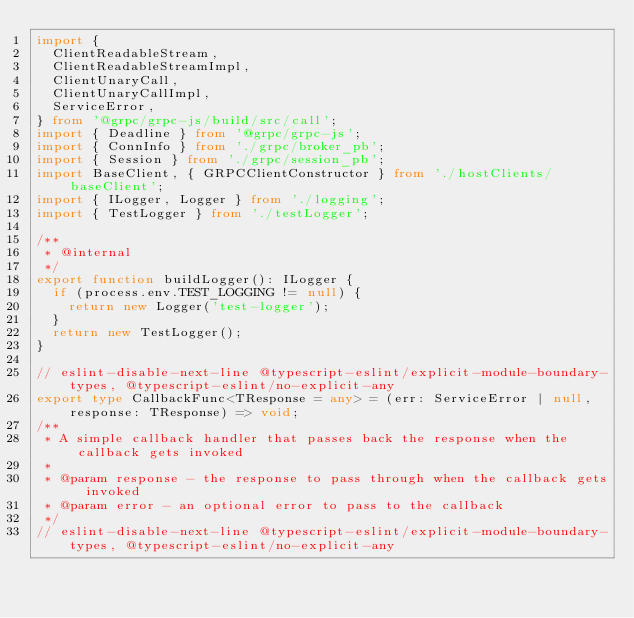<code> <loc_0><loc_0><loc_500><loc_500><_TypeScript_>import {
  ClientReadableStream,
  ClientReadableStreamImpl,
  ClientUnaryCall,
  ClientUnaryCallImpl,
  ServiceError,
} from '@grpc/grpc-js/build/src/call';
import { Deadline } from '@grpc/grpc-js';
import { ConnInfo } from './grpc/broker_pb';
import { Session } from './grpc/session_pb';
import BaseClient, { GRPCClientConstructor } from './hostClients/baseClient';
import { ILogger, Logger } from './logging';
import { TestLogger } from './testLogger';

/**
 * @internal
 */
export function buildLogger(): ILogger {
  if (process.env.TEST_LOGGING != null) {
    return new Logger('test-logger');
  }
  return new TestLogger();
}

// eslint-disable-next-line @typescript-eslint/explicit-module-boundary-types, @typescript-eslint/no-explicit-any
export type CallbackFunc<TResponse = any> = (err: ServiceError | null, response: TResponse) => void;
/**
 * A simple callback handler that passes back the response when the callback gets invoked
 *
 * @param response - the response to pass through when the callback gets invoked
 * @param error - an optional error to pass to the callback
 */
// eslint-disable-next-line @typescript-eslint/explicit-module-boundary-types, @typescript-eslint/no-explicit-any</code> 